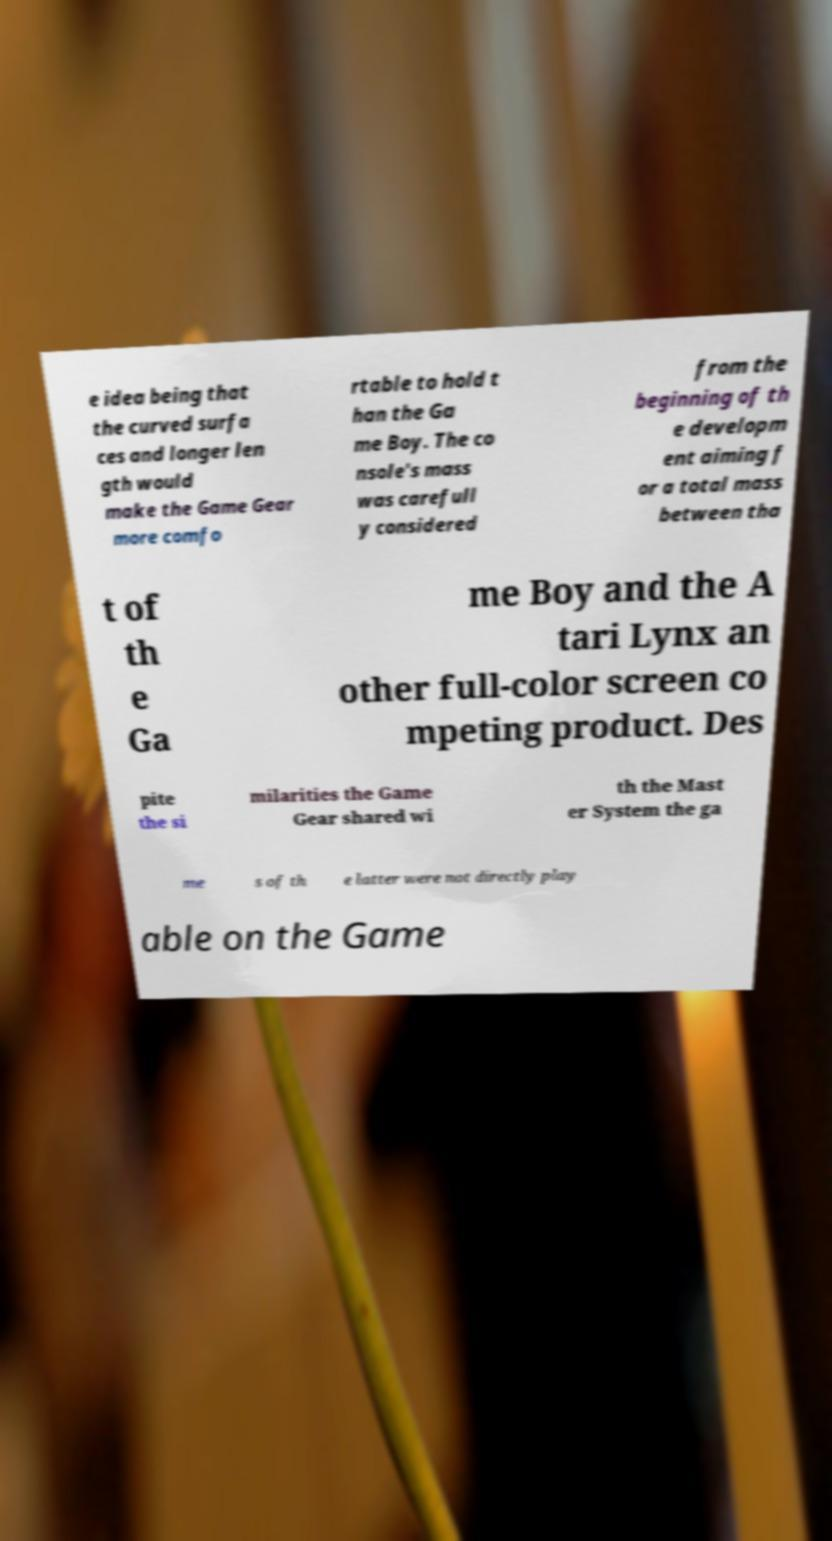Please read and relay the text visible in this image. What does it say? e idea being that the curved surfa ces and longer len gth would make the Game Gear more comfo rtable to hold t han the Ga me Boy. The co nsole's mass was carefull y considered from the beginning of th e developm ent aiming f or a total mass between tha t of th e Ga me Boy and the A tari Lynx an other full-color screen co mpeting product. Des pite the si milarities the Game Gear shared wi th the Mast er System the ga me s of th e latter were not directly play able on the Game 